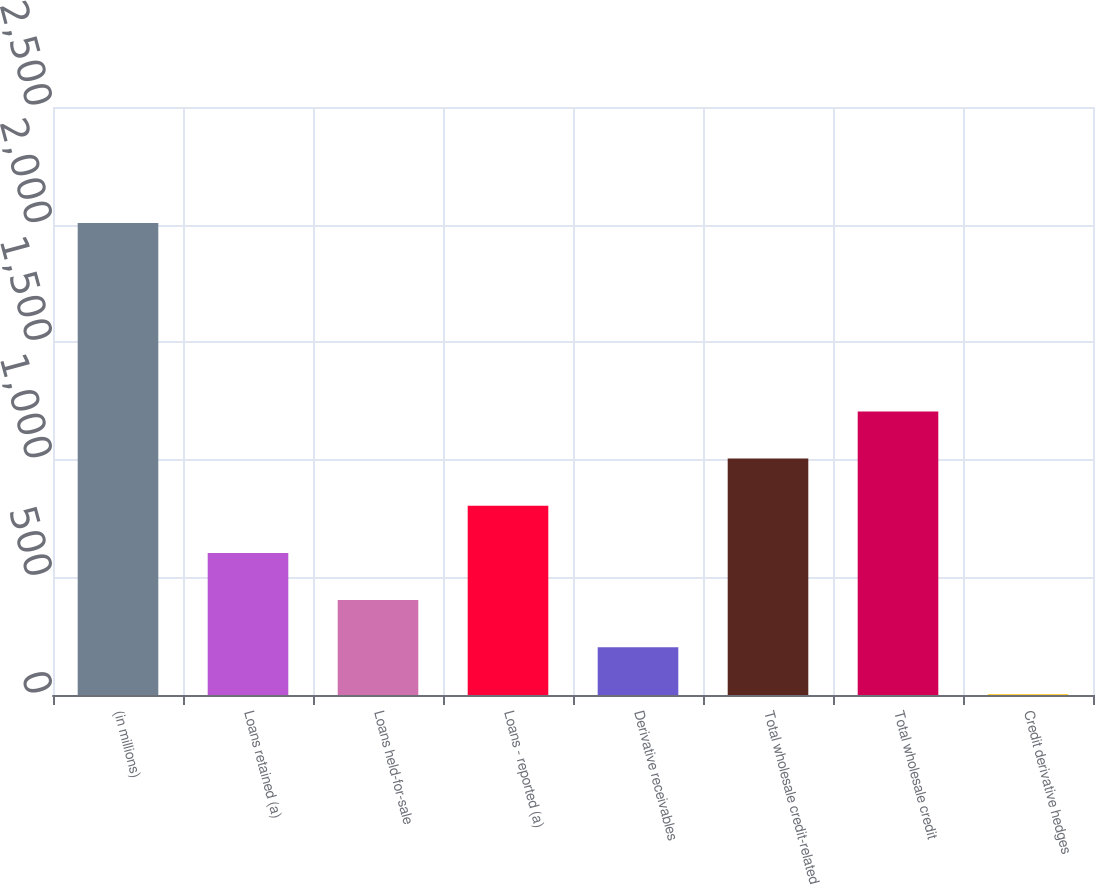<chart> <loc_0><loc_0><loc_500><loc_500><bar_chart><fcel>(in millions)<fcel>Loans retained (a)<fcel>Loans held-for-sale<fcel>Loans - reported (a)<fcel>Derivative receivables<fcel>Total wholesale credit-related<fcel>Total wholesale credit<fcel>Credit derivative hedges<nl><fcel>2007<fcel>604.2<fcel>403.8<fcel>804.6<fcel>203.4<fcel>1005<fcel>1205.4<fcel>3<nl></chart> 